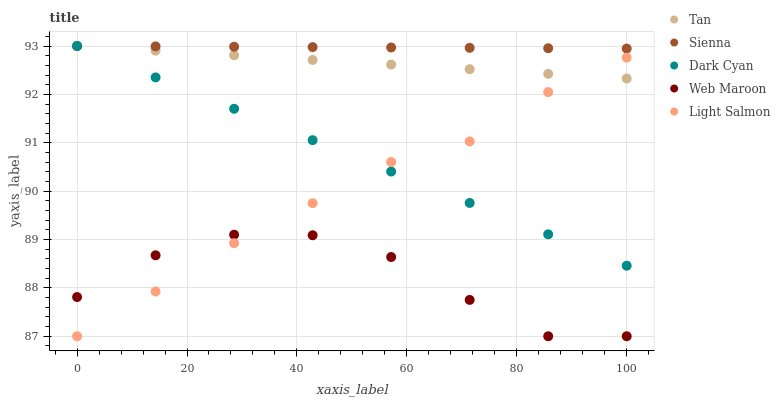Does Web Maroon have the minimum area under the curve?
Answer yes or no. Yes. Does Sienna have the maximum area under the curve?
Answer yes or no. Yes. Does Dark Cyan have the minimum area under the curve?
Answer yes or no. No. Does Dark Cyan have the maximum area under the curve?
Answer yes or no. No. Is Sienna the smoothest?
Answer yes or no. Yes. Is Web Maroon the roughest?
Answer yes or no. Yes. Is Dark Cyan the smoothest?
Answer yes or no. No. Is Dark Cyan the roughest?
Answer yes or no. No. Does Web Maroon have the lowest value?
Answer yes or no. Yes. Does Dark Cyan have the lowest value?
Answer yes or no. No. Does Tan have the highest value?
Answer yes or no. Yes. Does Web Maroon have the highest value?
Answer yes or no. No. Is Web Maroon less than Tan?
Answer yes or no. Yes. Is Tan greater than Web Maroon?
Answer yes or no. Yes. Does Sienna intersect Dark Cyan?
Answer yes or no. Yes. Is Sienna less than Dark Cyan?
Answer yes or no. No. Is Sienna greater than Dark Cyan?
Answer yes or no. No. Does Web Maroon intersect Tan?
Answer yes or no. No. 